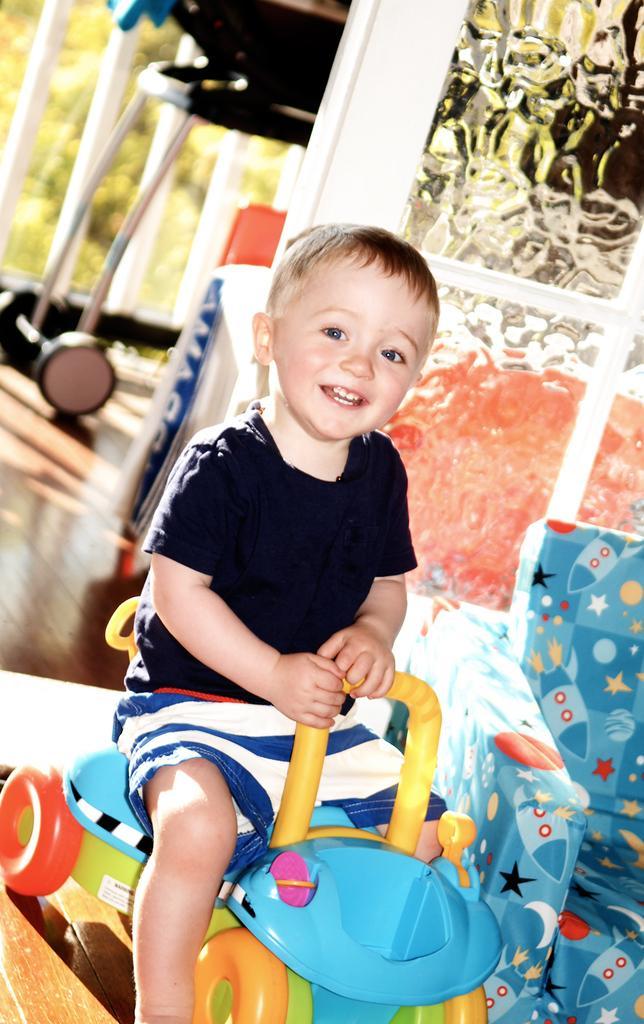Describe this image in one or two sentences. In this image we can see a child sitting on a toy. On the right side there is a sofa chair. In the back there is a wall. In the background it is looking blur. 